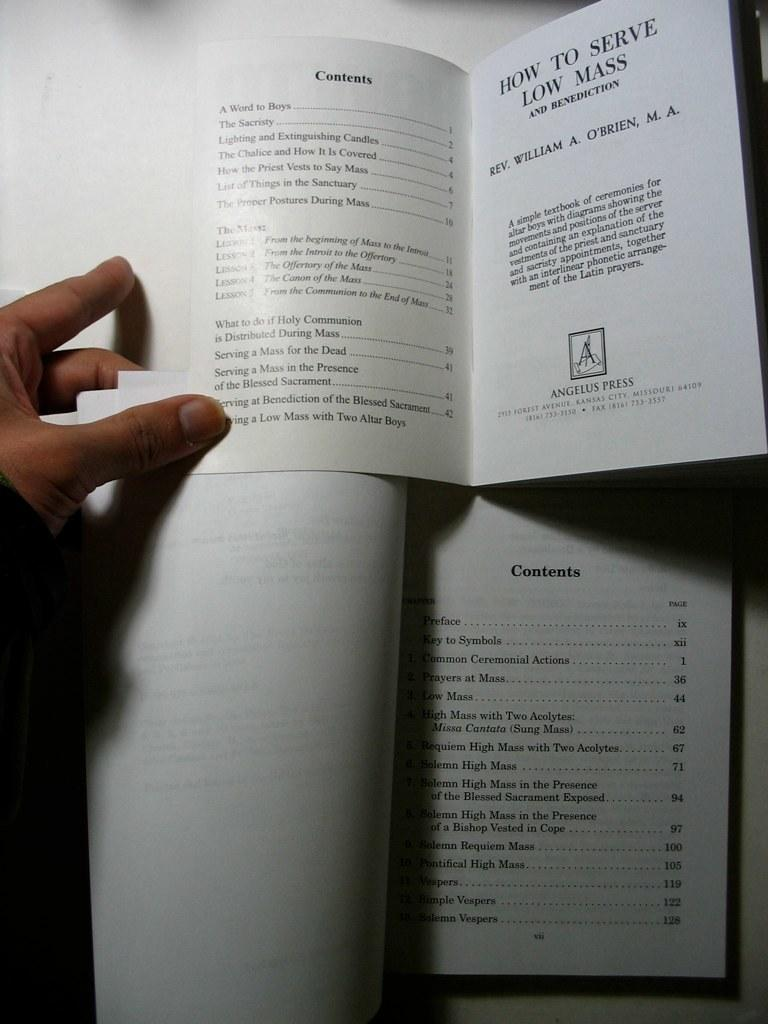Provide a one-sentence caption for the provided image. A hand holds open two books' index pages concering how to serve low mass. 